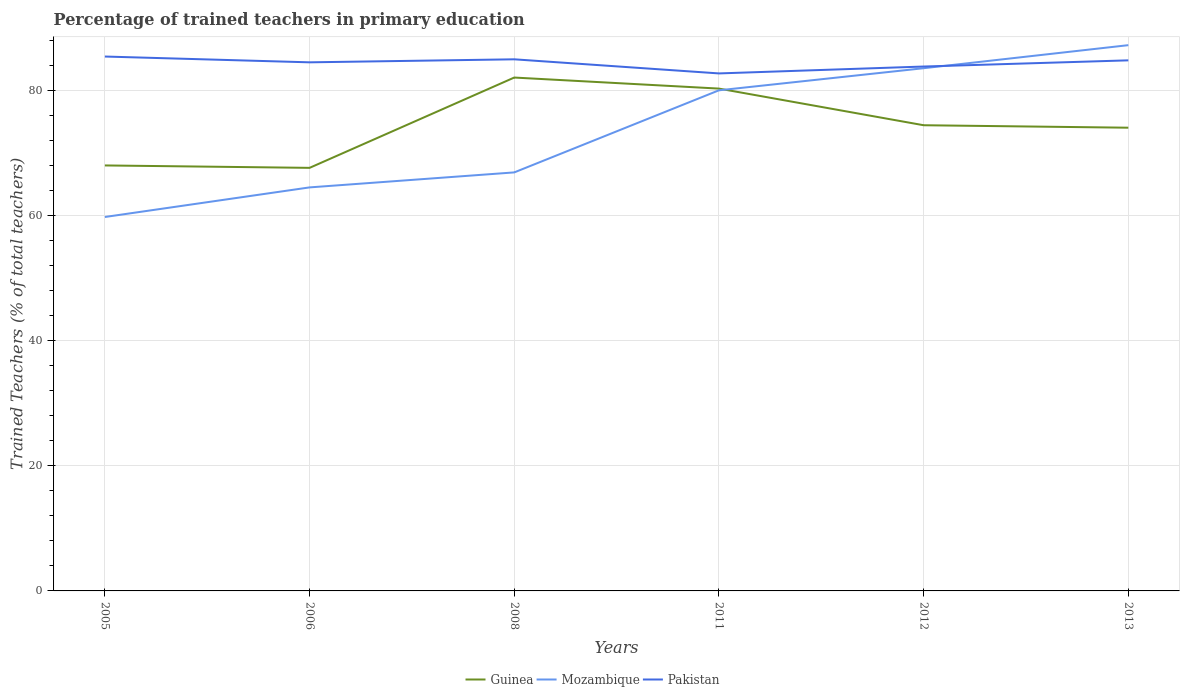Does the line corresponding to Pakistan intersect with the line corresponding to Guinea?
Keep it short and to the point. No. Is the number of lines equal to the number of legend labels?
Your answer should be compact. Yes. Across all years, what is the maximum percentage of trained teachers in Mozambique?
Provide a succinct answer. 59.83. In which year was the percentage of trained teachers in Pakistan maximum?
Offer a terse response. 2011. What is the total percentage of trained teachers in Mozambique in the graph?
Your answer should be compact. -7.22. What is the difference between the highest and the second highest percentage of trained teachers in Mozambique?
Give a very brief answer. 27.49. How many lines are there?
Your answer should be very brief. 3. What is the difference between two consecutive major ticks on the Y-axis?
Provide a succinct answer. 20. Does the graph contain any zero values?
Provide a succinct answer. No. Does the graph contain grids?
Give a very brief answer. Yes. Where does the legend appear in the graph?
Provide a short and direct response. Bottom center. How are the legend labels stacked?
Make the answer very short. Horizontal. What is the title of the graph?
Give a very brief answer. Percentage of trained teachers in primary education. Does "Guinea" appear as one of the legend labels in the graph?
Make the answer very short. Yes. What is the label or title of the X-axis?
Your answer should be very brief. Years. What is the label or title of the Y-axis?
Ensure brevity in your answer.  Trained Teachers (% of total teachers). What is the Trained Teachers (% of total teachers) of Guinea in 2005?
Offer a very short reply. 68.08. What is the Trained Teachers (% of total teachers) in Mozambique in 2005?
Your answer should be compact. 59.83. What is the Trained Teachers (% of total teachers) of Pakistan in 2005?
Keep it short and to the point. 85.51. What is the Trained Teachers (% of total teachers) in Guinea in 2006?
Keep it short and to the point. 67.7. What is the Trained Teachers (% of total teachers) of Mozambique in 2006?
Ensure brevity in your answer.  64.57. What is the Trained Teachers (% of total teachers) in Pakistan in 2006?
Ensure brevity in your answer.  84.58. What is the Trained Teachers (% of total teachers) of Guinea in 2008?
Provide a short and direct response. 82.15. What is the Trained Teachers (% of total teachers) in Mozambique in 2008?
Make the answer very short. 66.97. What is the Trained Teachers (% of total teachers) of Pakistan in 2008?
Provide a succinct answer. 85.06. What is the Trained Teachers (% of total teachers) of Guinea in 2011?
Ensure brevity in your answer.  80.38. What is the Trained Teachers (% of total teachers) in Mozambique in 2011?
Make the answer very short. 80.1. What is the Trained Teachers (% of total teachers) of Pakistan in 2011?
Make the answer very short. 82.81. What is the Trained Teachers (% of total teachers) in Guinea in 2012?
Provide a short and direct response. 74.51. What is the Trained Teachers (% of total teachers) of Mozambique in 2012?
Make the answer very short. 83.64. What is the Trained Teachers (% of total teachers) in Pakistan in 2012?
Provide a short and direct response. 83.91. What is the Trained Teachers (% of total teachers) in Guinea in 2013?
Offer a terse response. 74.12. What is the Trained Teachers (% of total teachers) of Mozambique in 2013?
Offer a terse response. 87.33. What is the Trained Teachers (% of total teachers) in Pakistan in 2013?
Your response must be concise. 84.9. Across all years, what is the maximum Trained Teachers (% of total teachers) in Guinea?
Your answer should be compact. 82.15. Across all years, what is the maximum Trained Teachers (% of total teachers) of Mozambique?
Keep it short and to the point. 87.33. Across all years, what is the maximum Trained Teachers (% of total teachers) of Pakistan?
Your answer should be compact. 85.51. Across all years, what is the minimum Trained Teachers (% of total teachers) of Guinea?
Your answer should be very brief. 67.7. Across all years, what is the minimum Trained Teachers (% of total teachers) of Mozambique?
Give a very brief answer. 59.83. Across all years, what is the minimum Trained Teachers (% of total teachers) of Pakistan?
Give a very brief answer. 82.81. What is the total Trained Teachers (% of total teachers) in Guinea in the graph?
Offer a terse response. 446.93. What is the total Trained Teachers (% of total teachers) in Mozambique in the graph?
Your answer should be compact. 442.44. What is the total Trained Teachers (% of total teachers) of Pakistan in the graph?
Your answer should be very brief. 506.76. What is the difference between the Trained Teachers (% of total teachers) in Guinea in 2005 and that in 2006?
Offer a terse response. 0.39. What is the difference between the Trained Teachers (% of total teachers) of Mozambique in 2005 and that in 2006?
Ensure brevity in your answer.  -4.73. What is the difference between the Trained Teachers (% of total teachers) in Pakistan in 2005 and that in 2006?
Give a very brief answer. 0.93. What is the difference between the Trained Teachers (% of total teachers) in Guinea in 2005 and that in 2008?
Your answer should be very brief. -14.06. What is the difference between the Trained Teachers (% of total teachers) in Mozambique in 2005 and that in 2008?
Ensure brevity in your answer.  -7.13. What is the difference between the Trained Teachers (% of total teachers) of Pakistan in 2005 and that in 2008?
Your answer should be compact. 0.44. What is the difference between the Trained Teachers (% of total teachers) of Guinea in 2005 and that in 2011?
Offer a terse response. -12.29. What is the difference between the Trained Teachers (% of total teachers) of Mozambique in 2005 and that in 2011?
Provide a short and direct response. -20.27. What is the difference between the Trained Teachers (% of total teachers) of Pakistan in 2005 and that in 2011?
Provide a short and direct response. 2.7. What is the difference between the Trained Teachers (% of total teachers) of Guinea in 2005 and that in 2012?
Offer a very short reply. -6.43. What is the difference between the Trained Teachers (% of total teachers) of Mozambique in 2005 and that in 2012?
Your response must be concise. -23.81. What is the difference between the Trained Teachers (% of total teachers) of Pakistan in 2005 and that in 2012?
Your answer should be compact. 1.6. What is the difference between the Trained Teachers (% of total teachers) in Guinea in 2005 and that in 2013?
Offer a terse response. -6.04. What is the difference between the Trained Teachers (% of total teachers) of Mozambique in 2005 and that in 2013?
Your answer should be compact. -27.49. What is the difference between the Trained Teachers (% of total teachers) in Pakistan in 2005 and that in 2013?
Your answer should be compact. 0.61. What is the difference between the Trained Teachers (% of total teachers) of Guinea in 2006 and that in 2008?
Give a very brief answer. -14.45. What is the difference between the Trained Teachers (% of total teachers) in Mozambique in 2006 and that in 2008?
Ensure brevity in your answer.  -2.4. What is the difference between the Trained Teachers (% of total teachers) of Pakistan in 2006 and that in 2008?
Give a very brief answer. -0.48. What is the difference between the Trained Teachers (% of total teachers) of Guinea in 2006 and that in 2011?
Offer a terse response. -12.68. What is the difference between the Trained Teachers (% of total teachers) of Mozambique in 2006 and that in 2011?
Provide a succinct answer. -15.54. What is the difference between the Trained Teachers (% of total teachers) in Pakistan in 2006 and that in 2011?
Give a very brief answer. 1.77. What is the difference between the Trained Teachers (% of total teachers) of Guinea in 2006 and that in 2012?
Your answer should be compact. -6.82. What is the difference between the Trained Teachers (% of total teachers) of Mozambique in 2006 and that in 2012?
Your answer should be compact. -19.07. What is the difference between the Trained Teachers (% of total teachers) in Pakistan in 2006 and that in 2012?
Provide a succinct answer. 0.67. What is the difference between the Trained Teachers (% of total teachers) in Guinea in 2006 and that in 2013?
Your answer should be very brief. -6.42. What is the difference between the Trained Teachers (% of total teachers) in Mozambique in 2006 and that in 2013?
Give a very brief answer. -22.76. What is the difference between the Trained Teachers (% of total teachers) of Pakistan in 2006 and that in 2013?
Make the answer very short. -0.32. What is the difference between the Trained Teachers (% of total teachers) in Guinea in 2008 and that in 2011?
Provide a short and direct response. 1.77. What is the difference between the Trained Teachers (% of total teachers) of Mozambique in 2008 and that in 2011?
Provide a short and direct response. -13.14. What is the difference between the Trained Teachers (% of total teachers) in Pakistan in 2008 and that in 2011?
Offer a very short reply. 2.26. What is the difference between the Trained Teachers (% of total teachers) of Guinea in 2008 and that in 2012?
Provide a succinct answer. 7.63. What is the difference between the Trained Teachers (% of total teachers) of Mozambique in 2008 and that in 2012?
Keep it short and to the point. -16.67. What is the difference between the Trained Teachers (% of total teachers) of Pakistan in 2008 and that in 2012?
Provide a succinct answer. 1.16. What is the difference between the Trained Teachers (% of total teachers) in Guinea in 2008 and that in 2013?
Give a very brief answer. 8.03. What is the difference between the Trained Teachers (% of total teachers) of Mozambique in 2008 and that in 2013?
Provide a short and direct response. -20.36. What is the difference between the Trained Teachers (% of total teachers) of Pakistan in 2008 and that in 2013?
Keep it short and to the point. 0.16. What is the difference between the Trained Teachers (% of total teachers) in Guinea in 2011 and that in 2012?
Provide a succinct answer. 5.86. What is the difference between the Trained Teachers (% of total teachers) in Mozambique in 2011 and that in 2012?
Offer a terse response. -3.54. What is the difference between the Trained Teachers (% of total teachers) of Pakistan in 2011 and that in 2012?
Make the answer very short. -1.1. What is the difference between the Trained Teachers (% of total teachers) of Guinea in 2011 and that in 2013?
Ensure brevity in your answer.  6.26. What is the difference between the Trained Teachers (% of total teachers) of Mozambique in 2011 and that in 2013?
Your response must be concise. -7.22. What is the difference between the Trained Teachers (% of total teachers) of Pakistan in 2011 and that in 2013?
Give a very brief answer. -2.09. What is the difference between the Trained Teachers (% of total teachers) of Guinea in 2012 and that in 2013?
Your answer should be compact. 0.4. What is the difference between the Trained Teachers (% of total teachers) of Mozambique in 2012 and that in 2013?
Provide a succinct answer. -3.69. What is the difference between the Trained Teachers (% of total teachers) in Pakistan in 2012 and that in 2013?
Keep it short and to the point. -0.99. What is the difference between the Trained Teachers (% of total teachers) of Guinea in 2005 and the Trained Teachers (% of total teachers) of Mozambique in 2006?
Your response must be concise. 3.51. What is the difference between the Trained Teachers (% of total teachers) of Guinea in 2005 and the Trained Teachers (% of total teachers) of Pakistan in 2006?
Your answer should be compact. -16.5. What is the difference between the Trained Teachers (% of total teachers) of Mozambique in 2005 and the Trained Teachers (% of total teachers) of Pakistan in 2006?
Keep it short and to the point. -24.75. What is the difference between the Trained Teachers (% of total teachers) of Guinea in 2005 and the Trained Teachers (% of total teachers) of Mozambique in 2008?
Your response must be concise. 1.11. What is the difference between the Trained Teachers (% of total teachers) in Guinea in 2005 and the Trained Teachers (% of total teachers) in Pakistan in 2008?
Your answer should be very brief. -16.98. What is the difference between the Trained Teachers (% of total teachers) of Mozambique in 2005 and the Trained Teachers (% of total teachers) of Pakistan in 2008?
Make the answer very short. -25.23. What is the difference between the Trained Teachers (% of total teachers) in Guinea in 2005 and the Trained Teachers (% of total teachers) in Mozambique in 2011?
Make the answer very short. -12.02. What is the difference between the Trained Teachers (% of total teachers) in Guinea in 2005 and the Trained Teachers (% of total teachers) in Pakistan in 2011?
Your response must be concise. -14.72. What is the difference between the Trained Teachers (% of total teachers) in Mozambique in 2005 and the Trained Teachers (% of total teachers) in Pakistan in 2011?
Offer a very short reply. -22.97. What is the difference between the Trained Teachers (% of total teachers) in Guinea in 2005 and the Trained Teachers (% of total teachers) in Mozambique in 2012?
Provide a short and direct response. -15.56. What is the difference between the Trained Teachers (% of total teachers) in Guinea in 2005 and the Trained Teachers (% of total teachers) in Pakistan in 2012?
Ensure brevity in your answer.  -15.83. What is the difference between the Trained Teachers (% of total teachers) in Mozambique in 2005 and the Trained Teachers (% of total teachers) in Pakistan in 2012?
Your answer should be very brief. -24.07. What is the difference between the Trained Teachers (% of total teachers) in Guinea in 2005 and the Trained Teachers (% of total teachers) in Mozambique in 2013?
Give a very brief answer. -19.24. What is the difference between the Trained Teachers (% of total teachers) in Guinea in 2005 and the Trained Teachers (% of total teachers) in Pakistan in 2013?
Your answer should be compact. -16.82. What is the difference between the Trained Teachers (% of total teachers) of Mozambique in 2005 and the Trained Teachers (% of total teachers) of Pakistan in 2013?
Your answer should be very brief. -25.07. What is the difference between the Trained Teachers (% of total teachers) of Guinea in 2006 and the Trained Teachers (% of total teachers) of Mozambique in 2008?
Your answer should be very brief. 0.73. What is the difference between the Trained Teachers (% of total teachers) of Guinea in 2006 and the Trained Teachers (% of total teachers) of Pakistan in 2008?
Provide a succinct answer. -17.37. What is the difference between the Trained Teachers (% of total teachers) of Mozambique in 2006 and the Trained Teachers (% of total teachers) of Pakistan in 2008?
Provide a short and direct response. -20.49. What is the difference between the Trained Teachers (% of total teachers) in Guinea in 2006 and the Trained Teachers (% of total teachers) in Mozambique in 2011?
Offer a terse response. -12.41. What is the difference between the Trained Teachers (% of total teachers) in Guinea in 2006 and the Trained Teachers (% of total teachers) in Pakistan in 2011?
Ensure brevity in your answer.  -15.11. What is the difference between the Trained Teachers (% of total teachers) of Mozambique in 2006 and the Trained Teachers (% of total teachers) of Pakistan in 2011?
Offer a very short reply. -18.24. What is the difference between the Trained Teachers (% of total teachers) of Guinea in 2006 and the Trained Teachers (% of total teachers) of Mozambique in 2012?
Your answer should be compact. -15.94. What is the difference between the Trained Teachers (% of total teachers) in Guinea in 2006 and the Trained Teachers (% of total teachers) in Pakistan in 2012?
Offer a terse response. -16.21. What is the difference between the Trained Teachers (% of total teachers) of Mozambique in 2006 and the Trained Teachers (% of total teachers) of Pakistan in 2012?
Give a very brief answer. -19.34. What is the difference between the Trained Teachers (% of total teachers) of Guinea in 2006 and the Trained Teachers (% of total teachers) of Mozambique in 2013?
Ensure brevity in your answer.  -19.63. What is the difference between the Trained Teachers (% of total teachers) of Guinea in 2006 and the Trained Teachers (% of total teachers) of Pakistan in 2013?
Keep it short and to the point. -17.2. What is the difference between the Trained Teachers (% of total teachers) of Mozambique in 2006 and the Trained Teachers (% of total teachers) of Pakistan in 2013?
Your answer should be compact. -20.33. What is the difference between the Trained Teachers (% of total teachers) of Guinea in 2008 and the Trained Teachers (% of total teachers) of Mozambique in 2011?
Your answer should be very brief. 2.04. What is the difference between the Trained Teachers (% of total teachers) in Guinea in 2008 and the Trained Teachers (% of total teachers) in Pakistan in 2011?
Offer a very short reply. -0.66. What is the difference between the Trained Teachers (% of total teachers) in Mozambique in 2008 and the Trained Teachers (% of total teachers) in Pakistan in 2011?
Give a very brief answer. -15.84. What is the difference between the Trained Teachers (% of total teachers) in Guinea in 2008 and the Trained Teachers (% of total teachers) in Mozambique in 2012?
Provide a succinct answer. -1.49. What is the difference between the Trained Teachers (% of total teachers) of Guinea in 2008 and the Trained Teachers (% of total teachers) of Pakistan in 2012?
Offer a terse response. -1.76. What is the difference between the Trained Teachers (% of total teachers) in Mozambique in 2008 and the Trained Teachers (% of total teachers) in Pakistan in 2012?
Your response must be concise. -16.94. What is the difference between the Trained Teachers (% of total teachers) in Guinea in 2008 and the Trained Teachers (% of total teachers) in Mozambique in 2013?
Offer a terse response. -5.18. What is the difference between the Trained Teachers (% of total teachers) of Guinea in 2008 and the Trained Teachers (% of total teachers) of Pakistan in 2013?
Ensure brevity in your answer.  -2.75. What is the difference between the Trained Teachers (% of total teachers) in Mozambique in 2008 and the Trained Teachers (% of total teachers) in Pakistan in 2013?
Offer a very short reply. -17.93. What is the difference between the Trained Teachers (% of total teachers) in Guinea in 2011 and the Trained Teachers (% of total teachers) in Mozambique in 2012?
Your answer should be compact. -3.26. What is the difference between the Trained Teachers (% of total teachers) of Guinea in 2011 and the Trained Teachers (% of total teachers) of Pakistan in 2012?
Make the answer very short. -3.53. What is the difference between the Trained Teachers (% of total teachers) of Mozambique in 2011 and the Trained Teachers (% of total teachers) of Pakistan in 2012?
Your answer should be compact. -3.8. What is the difference between the Trained Teachers (% of total teachers) of Guinea in 2011 and the Trained Teachers (% of total teachers) of Mozambique in 2013?
Give a very brief answer. -6.95. What is the difference between the Trained Teachers (% of total teachers) of Guinea in 2011 and the Trained Teachers (% of total teachers) of Pakistan in 2013?
Offer a terse response. -4.52. What is the difference between the Trained Teachers (% of total teachers) of Mozambique in 2011 and the Trained Teachers (% of total teachers) of Pakistan in 2013?
Make the answer very short. -4.79. What is the difference between the Trained Teachers (% of total teachers) in Guinea in 2012 and the Trained Teachers (% of total teachers) in Mozambique in 2013?
Your answer should be very brief. -12.81. What is the difference between the Trained Teachers (% of total teachers) of Guinea in 2012 and the Trained Teachers (% of total teachers) of Pakistan in 2013?
Your answer should be very brief. -10.38. What is the difference between the Trained Teachers (% of total teachers) in Mozambique in 2012 and the Trained Teachers (% of total teachers) in Pakistan in 2013?
Offer a very short reply. -1.26. What is the average Trained Teachers (% of total teachers) in Guinea per year?
Make the answer very short. 74.49. What is the average Trained Teachers (% of total teachers) of Mozambique per year?
Offer a terse response. 73.74. What is the average Trained Teachers (% of total teachers) in Pakistan per year?
Give a very brief answer. 84.46. In the year 2005, what is the difference between the Trained Teachers (% of total teachers) of Guinea and Trained Teachers (% of total teachers) of Mozambique?
Provide a succinct answer. 8.25. In the year 2005, what is the difference between the Trained Teachers (% of total teachers) in Guinea and Trained Teachers (% of total teachers) in Pakistan?
Provide a short and direct response. -17.42. In the year 2005, what is the difference between the Trained Teachers (% of total teachers) in Mozambique and Trained Teachers (% of total teachers) in Pakistan?
Offer a very short reply. -25.67. In the year 2006, what is the difference between the Trained Teachers (% of total teachers) of Guinea and Trained Teachers (% of total teachers) of Mozambique?
Your response must be concise. 3.13. In the year 2006, what is the difference between the Trained Teachers (% of total teachers) in Guinea and Trained Teachers (% of total teachers) in Pakistan?
Provide a short and direct response. -16.88. In the year 2006, what is the difference between the Trained Teachers (% of total teachers) of Mozambique and Trained Teachers (% of total teachers) of Pakistan?
Offer a terse response. -20.01. In the year 2008, what is the difference between the Trained Teachers (% of total teachers) in Guinea and Trained Teachers (% of total teachers) in Mozambique?
Your answer should be very brief. 15.18. In the year 2008, what is the difference between the Trained Teachers (% of total teachers) in Guinea and Trained Teachers (% of total teachers) in Pakistan?
Your response must be concise. -2.92. In the year 2008, what is the difference between the Trained Teachers (% of total teachers) in Mozambique and Trained Teachers (% of total teachers) in Pakistan?
Provide a succinct answer. -18.09. In the year 2011, what is the difference between the Trained Teachers (% of total teachers) of Guinea and Trained Teachers (% of total teachers) of Mozambique?
Provide a succinct answer. 0.27. In the year 2011, what is the difference between the Trained Teachers (% of total teachers) of Guinea and Trained Teachers (% of total teachers) of Pakistan?
Make the answer very short. -2.43. In the year 2011, what is the difference between the Trained Teachers (% of total teachers) of Mozambique and Trained Teachers (% of total teachers) of Pakistan?
Your answer should be very brief. -2.7. In the year 2012, what is the difference between the Trained Teachers (% of total teachers) of Guinea and Trained Teachers (% of total teachers) of Mozambique?
Your answer should be compact. -9.12. In the year 2012, what is the difference between the Trained Teachers (% of total teachers) in Guinea and Trained Teachers (% of total teachers) in Pakistan?
Provide a succinct answer. -9.39. In the year 2012, what is the difference between the Trained Teachers (% of total teachers) in Mozambique and Trained Teachers (% of total teachers) in Pakistan?
Offer a terse response. -0.27. In the year 2013, what is the difference between the Trained Teachers (% of total teachers) in Guinea and Trained Teachers (% of total teachers) in Mozambique?
Offer a very short reply. -13.21. In the year 2013, what is the difference between the Trained Teachers (% of total teachers) of Guinea and Trained Teachers (% of total teachers) of Pakistan?
Keep it short and to the point. -10.78. In the year 2013, what is the difference between the Trained Teachers (% of total teachers) in Mozambique and Trained Teachers (% of total teachers) in Pakistan?
Make the answer very short. 2.43. What is the ratio of the Trained Teachers (% of total teachers) of Guinea in 2005 to that in 2006?
Provide a short and direct response. 1.01. What is the ratio of the Trained Teachers (% of total teachers) of Mozambique in 2005 to that in 2006?
Ensure brevity in your answer.  0.93. What is the ratio of the Trained Teachers (% of total teachers) of Pakistan in 2005 to that in 2006?
Ensure brevity in your answer.  1.01. What is the ratio of the Trained Teachers (% of total teachers) of Guinea in 2005 to that in 2008?
Ensure brevity in your answer.  0.83. What is the ratio of the Trained Teachers (% of total teachers) of Mozambique in 2005 to that in 2008?
Keep it short and to the point. 0.89. What is the ratio of the Trained Teachers (% of total teachers) in Pakistan in 2005 to that in 2008?
Offer a very short reply. 1.01. What is the ratio of the Trained Teachers (% of total teachers) of Guinea in 2005 to that in 2011?
Provide a short and direct response. 0.85. What is the ratio of the Trained Teachers (% of total teachers) in Mozambique in 2005 to that in 2011?
Offer a terse response. 0.75. What is the ratio of the Trained Teachers (% of total teachers) in Pakistan in 2005 to that in 2011?
Ensure brevity in your answer.  1.03. What is the ratio of the Trained Teachers (% of total teachers) of Guinea in 2005 to that in 2012?
Make the answer very short. 0.91. What is the ratio of the Trained Teachers (% of total teachers) of Mozambique in 2005 to that in 2012?
Make the answer very short. 0.72. What is the ratio of the Trained Teachers (% of total teachers) in Pakistan in 2005 to that in 2012?
Keep it short and to the point. 1.02. What is the ratio of the Trained Teachers (% of total teachers) in Guinea in 2005 to that in 2013?
Your response must be concise. 0.92. What is the ratio of the Trained Teachers (% of total teachers) in Mozambique in 2005 to that in 2013?
Offer a very short reply. 0.69. What is the ratio of the Trained Teachers (% of total teachers) in Pakistan in 2005 to that in 2013?
Your answer should be compact. 1.01. What is the ratio of the Trained Teachers (% of total teachers) in Guinea in 2006 to that in 2008?
Your response must be concise. 0.82. What is the ratio of the Trained Teachers (% of total teachers) of Mozambique in 2006 to that in 2008?
Ensure brevity in your answer.  0.96. What is the ratio of the Trained Teachers (% of total teachers) in Guinea in 2006 to that in 2011?
Ensure brevity in your answer.  0.84. What is the ratio of the Trained Teachers (% of total teachers) of Mozambique in 2006 to that in 2011?
Provide a short and direct response. 0.81. What is the ratio of the Trained Teachers (% of total teachers) in Pakistan in 2006 to that in 2011?
Offer a terse response. 1.02. What is the ratio of the Trained Teachers (% of total teachers) in Guinea in 2006 to that in 2012?
Provide a short and direct response. 0.91. What is the ratio of the Trained Teachers (% of total teachers) in Mozambique in 2006 to that in 2012?
Your answer should be very brief. 0.77. What is the ratio of the Trained Teachers (% of total teachers) of Pakistan in 2006 to that in 2012?
Offer a terse response. 1.01. What is the ratio of the Trained Teachers (% of total teachers) of Guinea in 2006 to that in 2013?
Give a very brief answer. 0.91. What is the ratio of the Trained Teachers (% of total teachers) of Mozambique in 2006 to that in 2013?
Provide a short and direct response. 0.74. What is the ratio of the Trained Teachers (% of total teachers) of Guinea in 2008 to that in 2011?
Offer a terse response. 1.02. What is the ratio of the Trained Teachers (% of total teachers) of Mozambique in 2008 to that in 2011?
Offer a very short reply. 0.84. What is the ratio of the Trained Teachers (% of total teachers) in Pakistan in 2008 to that in 2011?
Your answer should be very brief. 1.03. What is the ratio of the Trained Teachers (% of total teachers) in Guinea in 2008 to that in 2012?
Your answer should be very brief. 1.1. What is the ratio of the Trained Teachers (% of total teachers) of Mozambique in 2008 to that in 2012?
Your answer should be very brief. 0.8. What is the ratio of the Trained Teachers (% of total teachers) in Pakistan in 2008 to that in 2012?
Provide a succinct answer. 1.01. What is the ratio of the Trained Teachers (% of total teachers) in Guinea in 2008 to that in 2013?
Make the answer very short. 1.11. What is the ratio of the Trained Teachers (% of total teachers) in Mozambique in 2008 to that in 2013?
Your answer should be very brief. 0.77. What is the ratio of the Trained Teachers (% of total teachers) of Guinea in 2011 to that in 2012?
Your response must be concise. 1.08. What is the ratio of the Trained Teachers (% of total teachers) of Mozambique in 2011 to that in 2012?
Give a very brief answer. 0.96. What is the ratio of the Trained Teachers (% of total teachers) of Pakistan in 2011 to that in 2012?
Your answer should be compact. 0.99. What is the ratio of the Trained Teachers (% of total teachers) of Guinea in 2011 to that in 2013?
Your answer should be very brief. 1.08. What is the ratio of the Trained Teachers (% of total teachers) of Mozambique in 2011 to that in 2013?
Offer a very short reply. 0.92. What is the ratio of the Trained Teachers (% of total teachers) in Pakistan in 2011 to that in 2013?
Your answer should be very brief. 0.98. What is the ratio of the Trained Teachers (% of total teachers) of Mozambique in 2012 to that in 2013?
Offer a terse response. 0.96. What is the ratio of the Trained Teachers (% of total teachers) in Pakistan in 2012 to that in 2013?
Offer a very short reply. 0.99. What is the difference between the highest and the second highest Trained Teachers (% of total teachers) of Guinea?
Offer a terse response. 1.77. What is the difference between the highest and the second highest Trained Teachers (% of total teachers) in Mozambique?
Keep it short and to the point. 3.69. What is the difference between the highest and the second highest Trained Teachers (% of total teachers) of Pakistan?
Make the answer very short. 0.44. What is the difference between the highest and the lowest Trained Teachers (% of total teachers) in Guinea?
Offer a terse response. 14.45. What is the difference between the highest and the lowest Trained Teachers (% of total teachers) of Mozambique?
Make the answer very short. 27.49. What is the difference between the highest and the lowest Trained Teachers (% of total teachers) in Pakistan?
Provide a succinct answer. 2.7. 